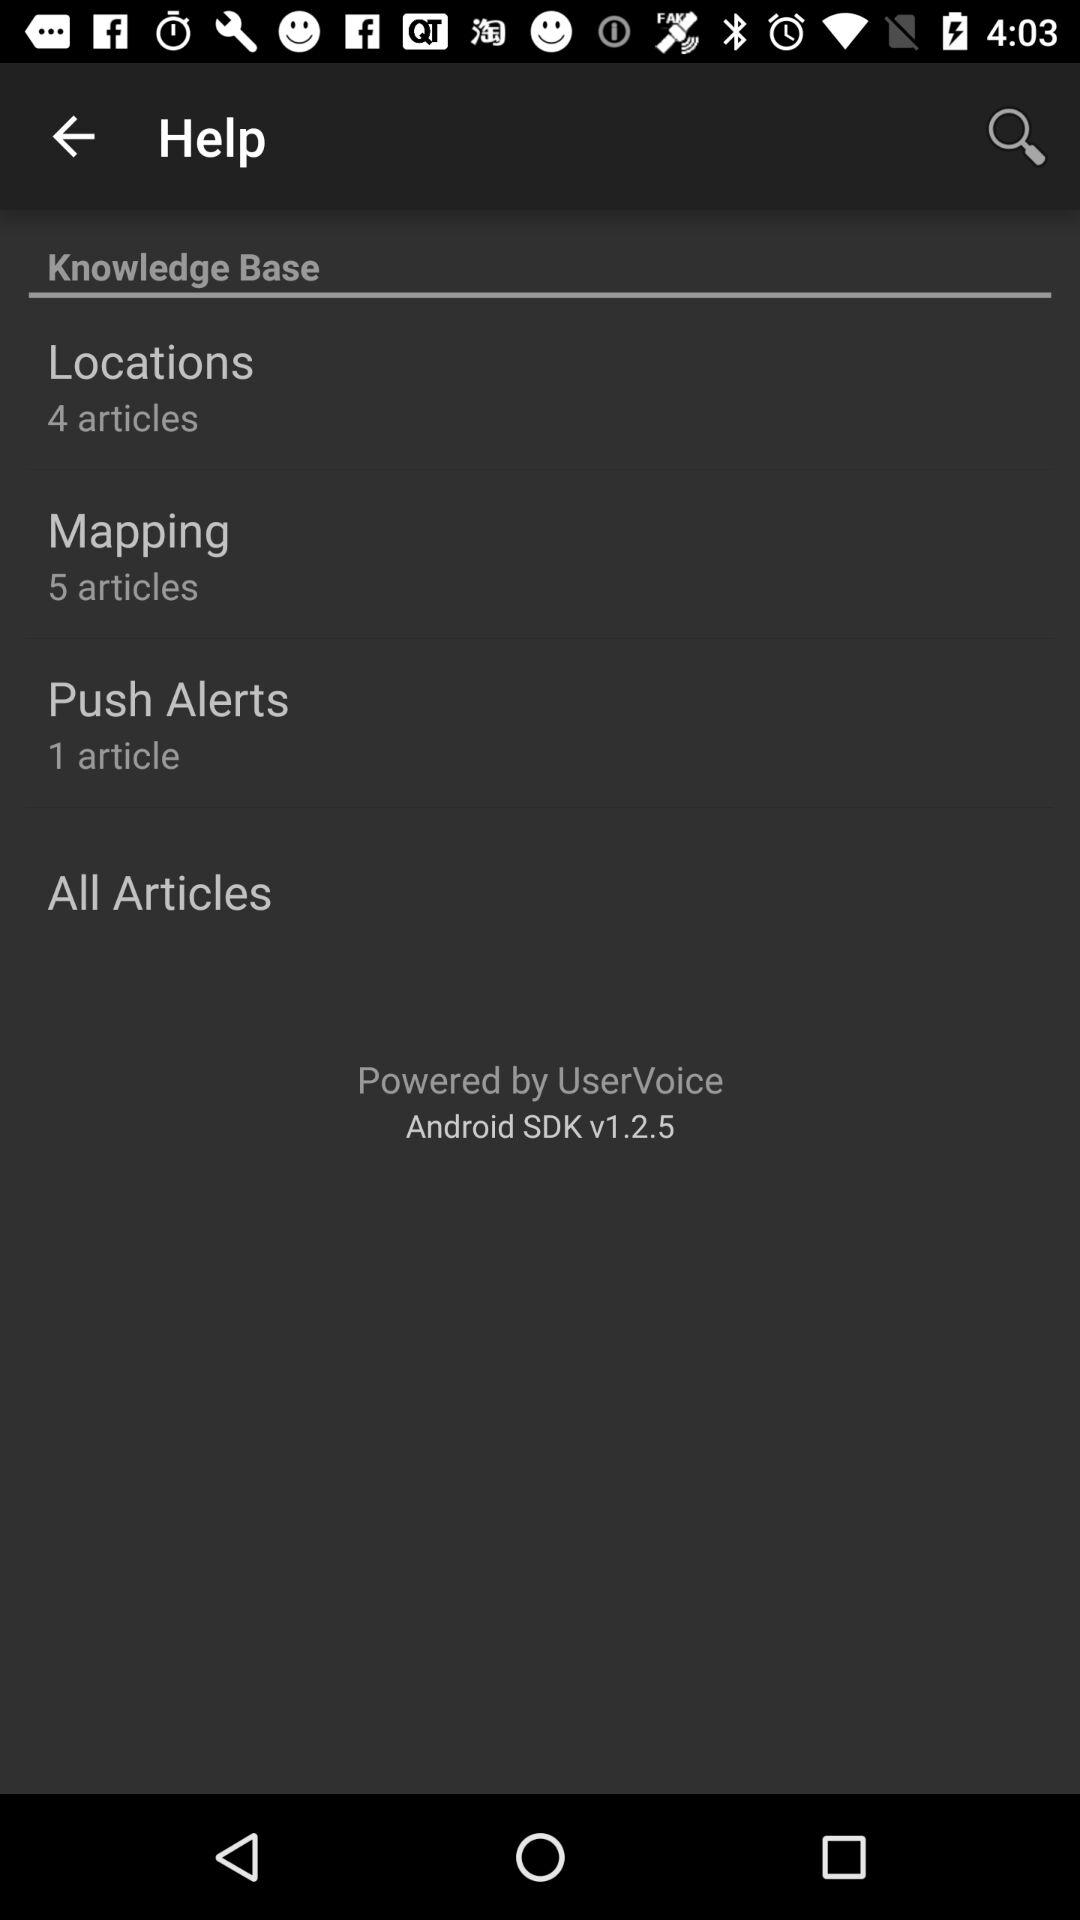What is the version? The version is Android SDK v1.2.5. 